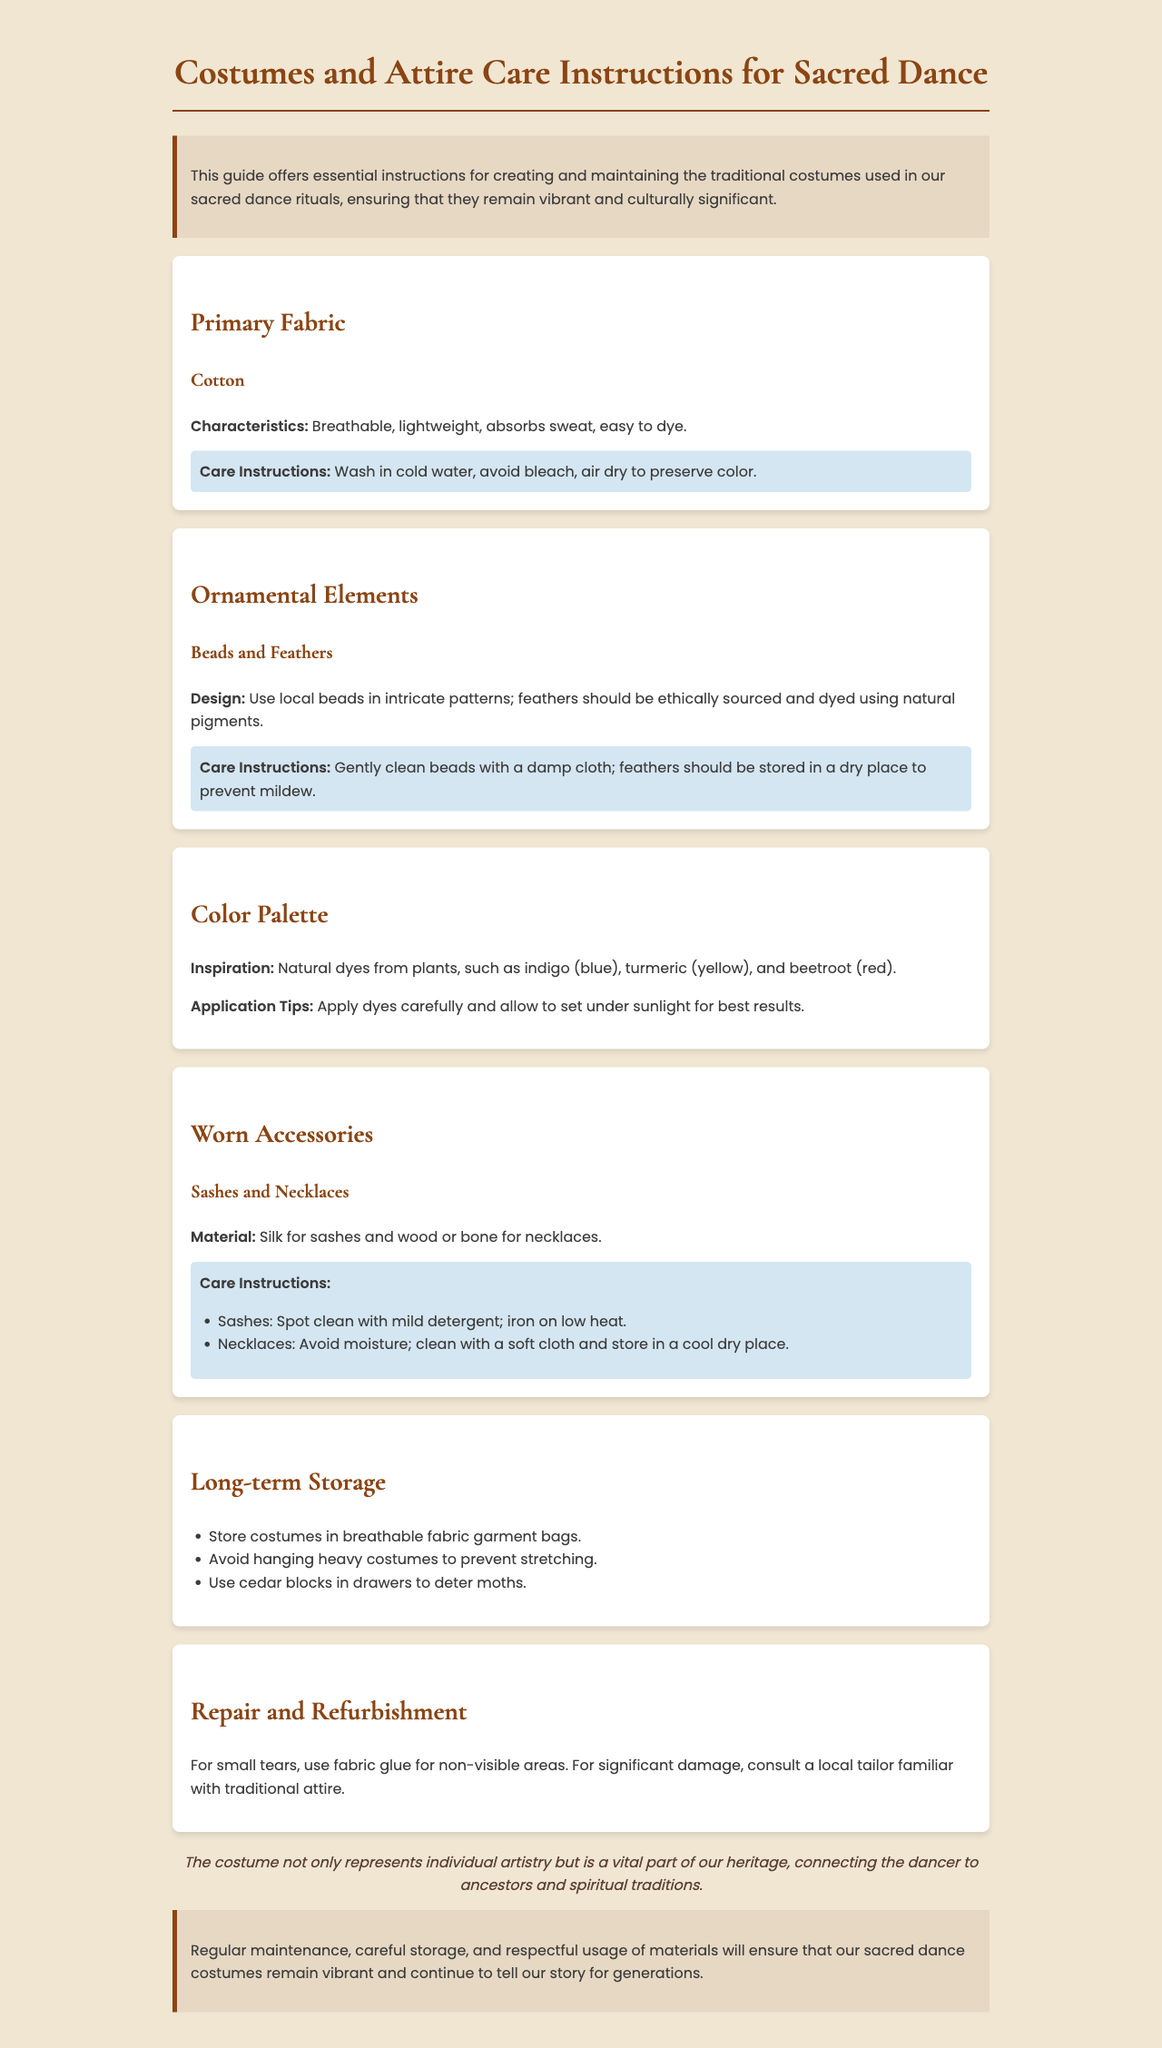What is the primary fabric used for costumes? The primary fabric section mentions that cotton is used for costumes.
Answer: Cotton What should you avoid using when washing cotton costumes? The care instructions for cotton indicate that bleach should be avoided.
Answer: Bleach What natural dye is mentioned for producing yellow color? The color palette section states that turmeric is used for yellow dye.
Answer: Turmeric What is suggested for cleaning necklaces? The care tips for necklaces recommend cleaning them with a soft cloth.
Answer: Soft cloth How should you store heavy costumes? The long-term storage section advises avoiding hanging heavy costumes to prevent stretching.
Answer: Avoid hanging What is recommended for spot cleaning sashes? The care instructions suggest using mild detergent for spot cleaning sashes.
Answer: Mild detergent What should be used in drawers to deter moths? The long-term storage section mentions using cedar blocks to deter moths.
Answer: Cedar blocks Where should costumes be stored? The long-term storage section specifies that costumes should be stored in breathable fabric garment bags.
Answer: Breathable fabric garment bags What should be done for significant damage to costumes? The repair and refurbishment section states to consult a local tailor for significant damage.
Answer: Consult a local tailor 